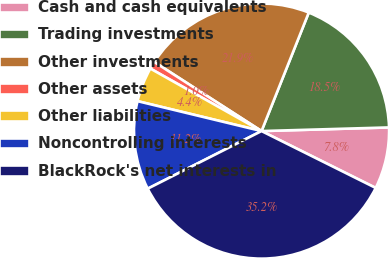Convert chart to OTSL. <chart><loc_0><loc_0><loc_500><loc_500><pie_chart><fcel>Cash and cash equivalents<fcel>Trading investments<fcel>Other investments<fcel>Other assets<fcel>Other liabilities<fcel>Noncontrolling interests<fcel>BlackRock's net interests in<nl><fcel>7.81%<fcel>18.51%<fcel>21.93%<fcel>0.96%<fcel>4.38%<fcel>11.23%<fcel>35.19%<nl></chart> 